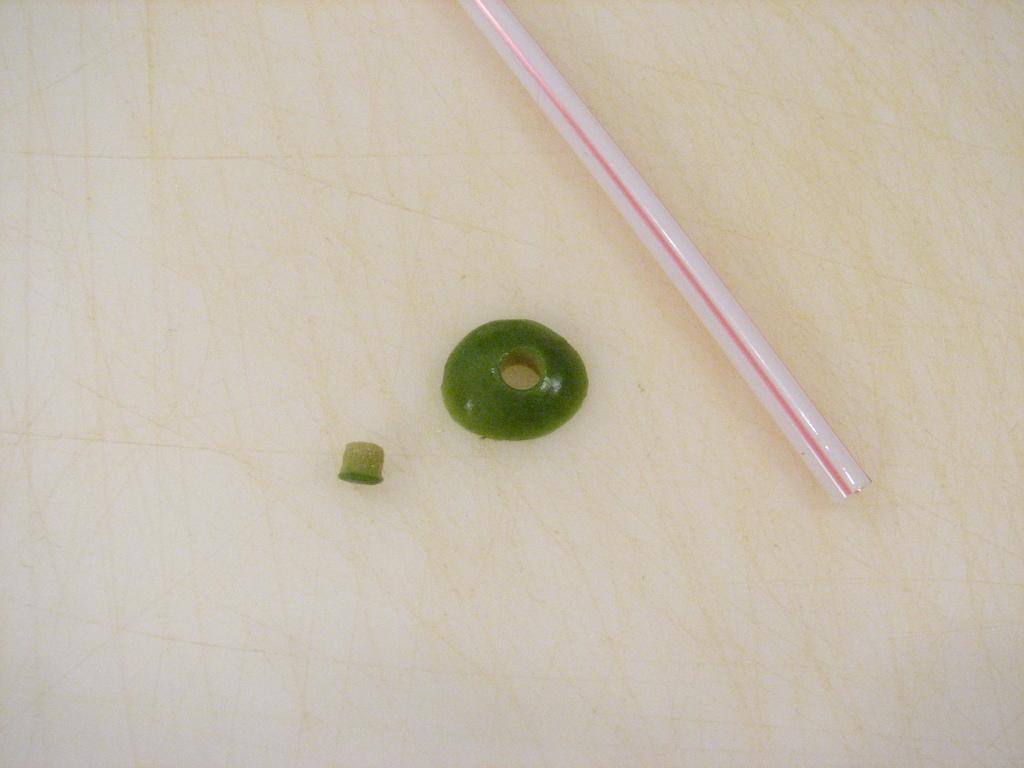What object is present in the image that is typically used for drinking? There is a straw in the image that is typically used for drinking. What color are the objects placed on the floor in the image? The objects placed on the floor in the image are green in color. Where are the straw and green color objects located in the image? The straw and green color objects are placed on the floor in the image. What type of shirt is being blown by the wind in the image? There is no shirt or wind present in the image; it only features a straw and green color objects placed on the floor. 